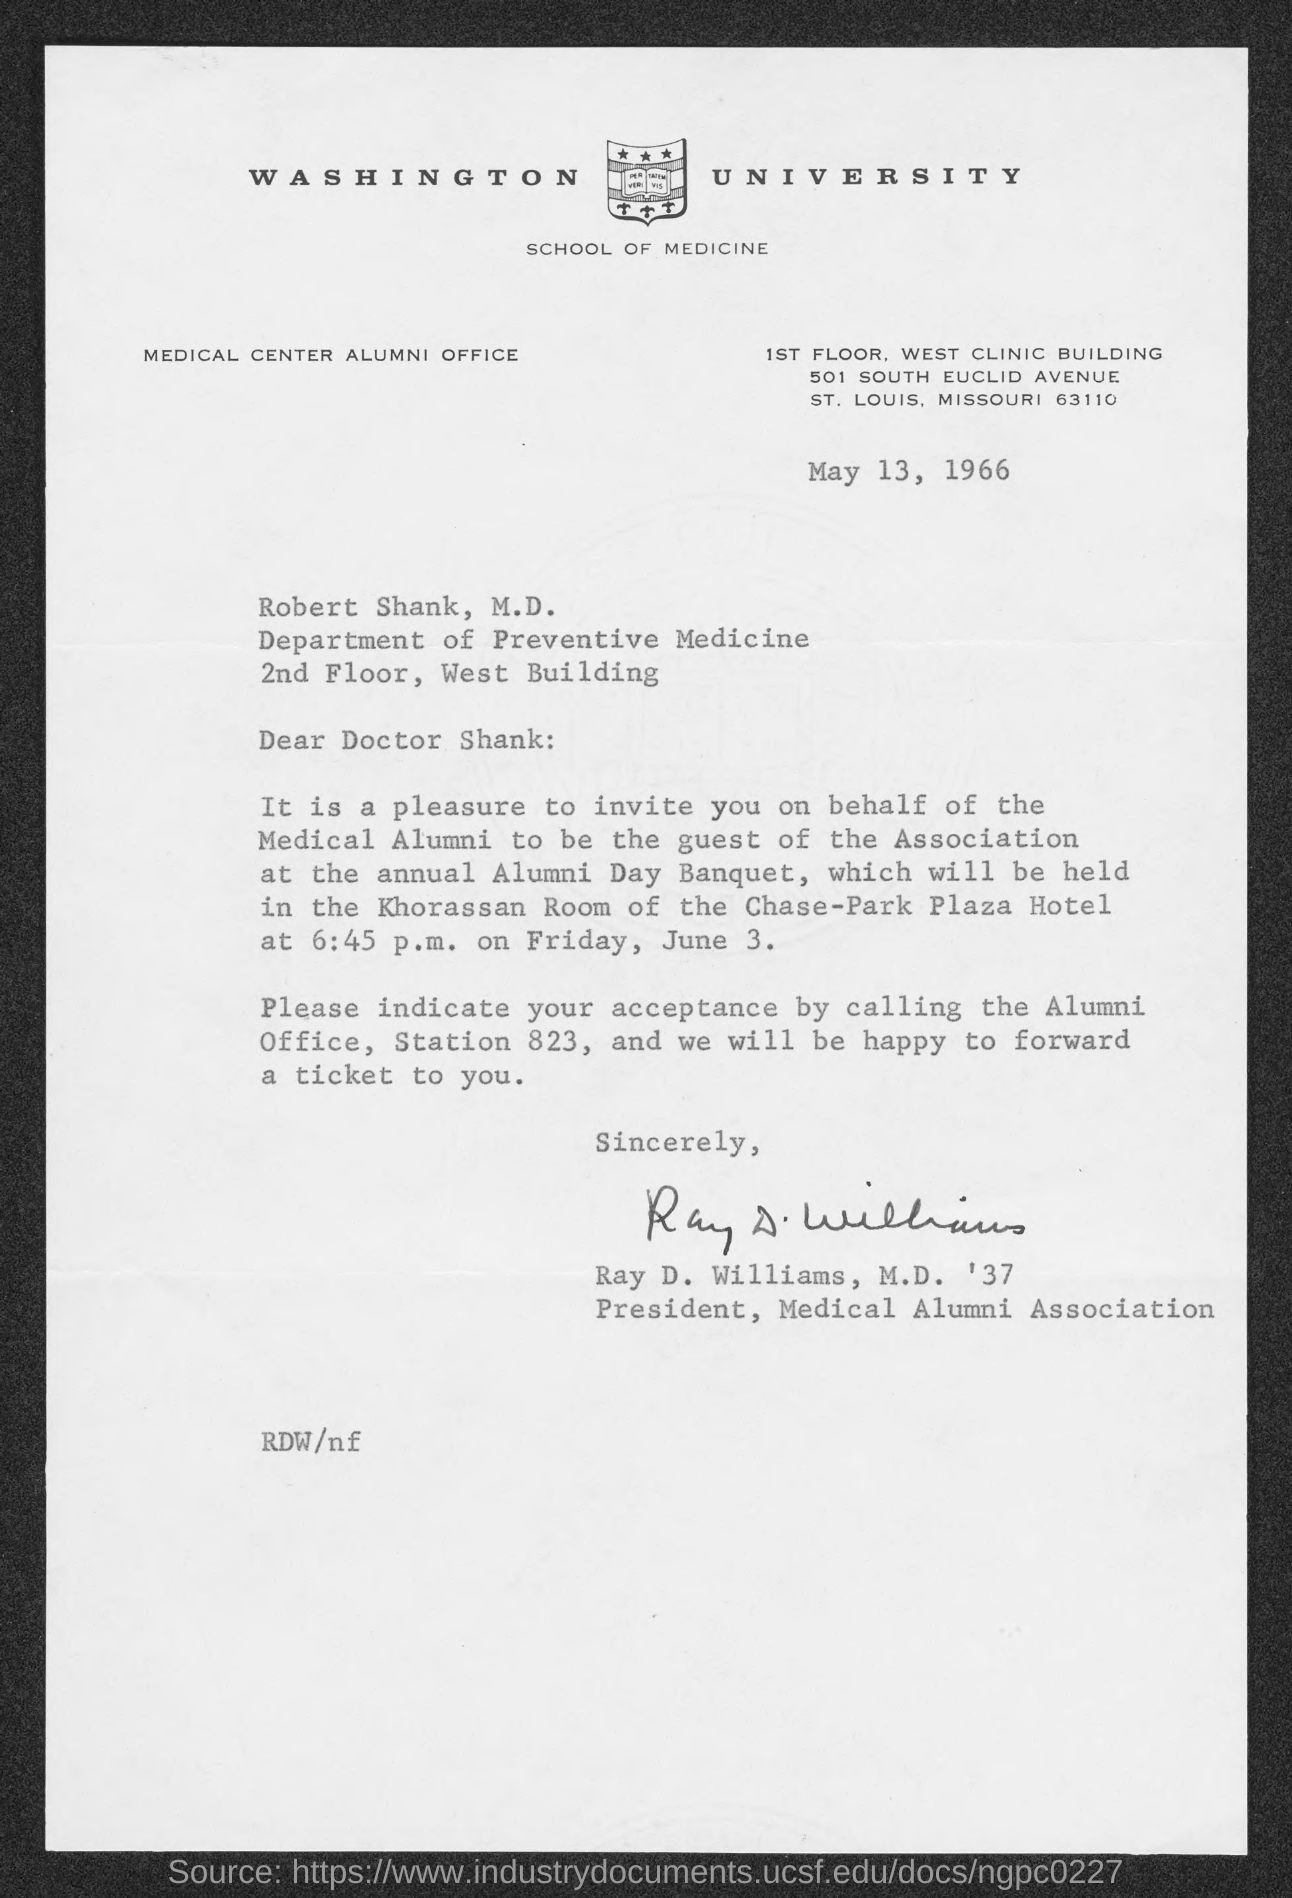List a handful of essential elements in this visual. Dr. Robert Shank M.D. is employed by the Department of Preventive Medicine. The issued date of this letter is May 13, 1966. Ray D. Williams, M.D. '37, has signed this letter. The letter head contains a reference to Washington University. Ray D. Williams, M.D. '37 holds the designation of President of the Medical Alumni Association. 